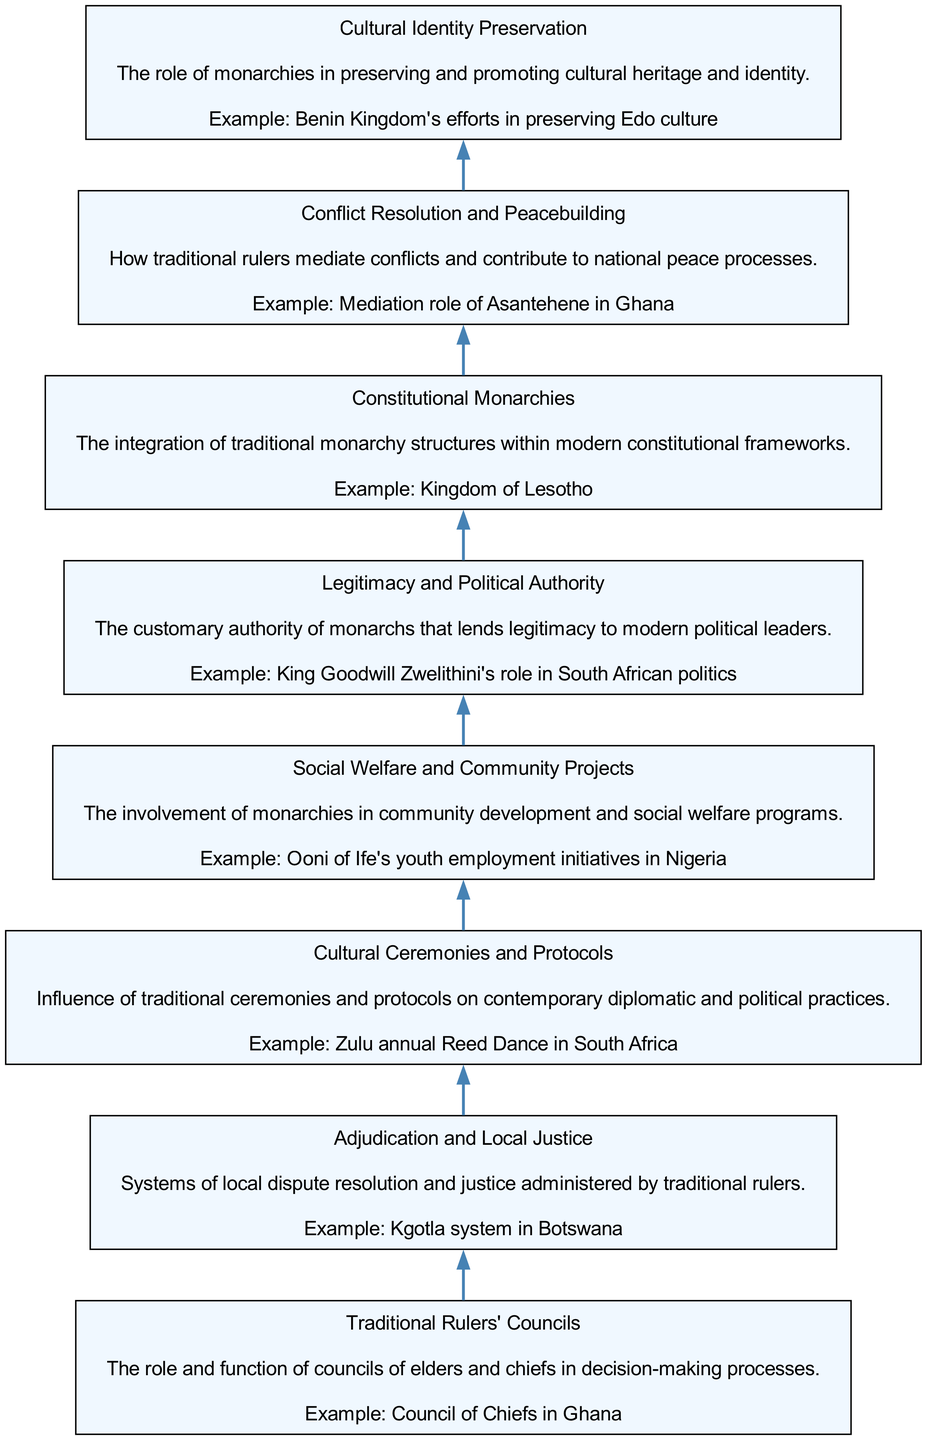What is the first element in the flow chart? The flow chart progresses from bottom to top, so the first element at the bottom is "Cultural Identity Preservation." This is evident as it is the initial node listed in the data and represents the starting point of the diagram.
Answer: Cultural Identity Preservation How many elements are in the flow chart? The diagram consists of eight distinct elements, as listed in the data provided. Each element covers different influences of African monarchies on modern governance practices.
Answer: Eight Which element follows "Social Welfare and Community Projects"? In the flow chart, "Social Welfare and Community Projects" is the fifth element, and it is directly followed by "Legitimacy and Political Authority," as the nodes are connected in sequential order.
Answer: Legitimacy and Political Authority What is the real-world example associated with "Adjudication and Local Justice"? The real-world example provided for "Adjudication and Local Justice" in the diagram is "Kgotla system in Botswana," which reflects the local dispute resolution practiced by traditional rulers.
Answer: Kgotla system in Botswana Which two elements specifically address conflict mediation? From the flow chart, "Conflict Resolution and Peacebuilding" and "Adjudication and Local Justice" both focus on aspects of conflict mediation, with "Conflict Resolution and Peacebuilding" addressing broader peace processes, while "Adjudication and Local Justice" addresses local dispute resolution.
Answer: Conflict Resolution and Peacebuilding, Adjudication and Local Justice How does "Legitimacy and Political Authority" relate to modern political leaders? "Legitimacy and Political Authority" connects to modern political leaders by illustrating how traditional rulers' customary authority enhances the legitimacy of these contemporary figures in governance, as indicated in the description of this element.
Answer: Enhances legitimacy What role do traditional ceremonies play in modern governance according to the flow chart? Traditional ceremonies are depicted in the chart as influencing contemporary diplomatic and political practices, as explained under the element "Cultural Ceremonies and Protocols." This shows their significance in shaping today's governance culture.
Answer: Influence contemporary practices What does the flow chart imply about traditional monarchies in constitutional frameworks? The flow chart suggests that traditional monarchies can be integrated within modern constitutional frameworks, demonstrating a coexistence that respects both traditional and contemporary governance structures, as highlighted under the element "Constitutional Monarchies."
Answer: Coexistence in governance structures 